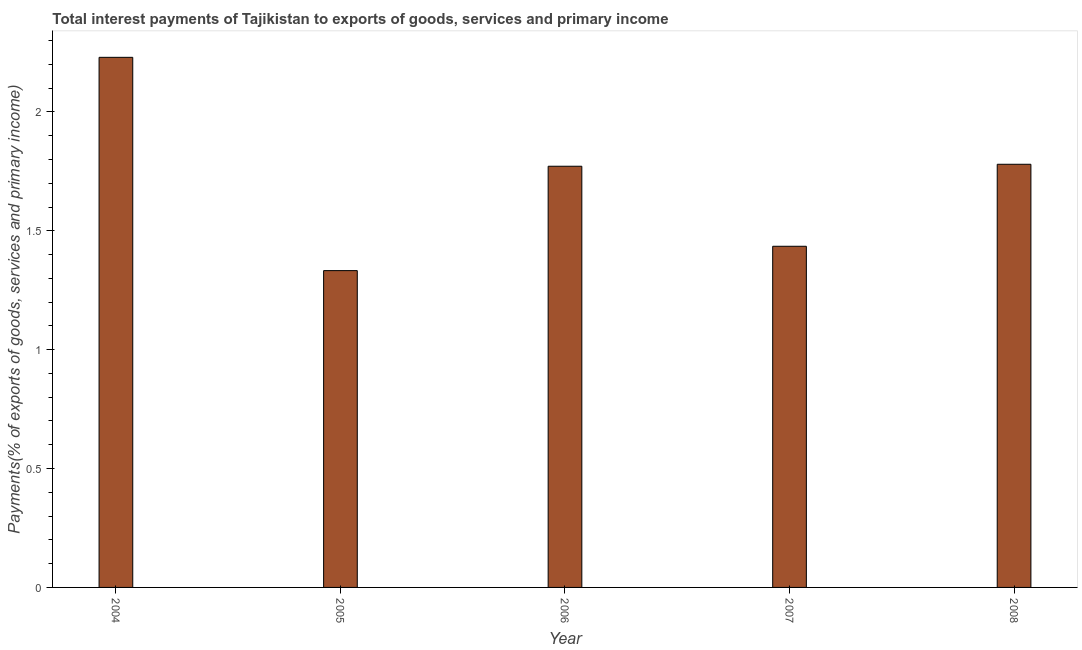Does the graph contain any zero values?
Make the answer very short. No. Does the graph contain grids?
Provide a succinct answer. No. What is the title of the graph?
Your response must be concise. Total interest payments of Tajikistan to exports of goods, services and primary income. What is the label or title of the X-axis?
Provide a succinct answer. Year. What is the label or title of the Y-axis?
Ensure brevity in your answer.  Payments(% of exports of goods, services and primary income). What is the total interest payments on external debt in 2006?
Offer a terse response. 1.77. Across all years, what is the maximum total interest payments on external debt?
Provide a short and direct response. 2.23. Across all years, what is the minimum total interest payments on external debt?
Offer a terse response. 1.33. What is the sum of the total interest payments on external debt?
Offer a terse response. 8.55. What is the difference between the total interest payments on external debt in 2004 and 2008?
Keep it short and to the point. 0.45. What is the average total interest payments on external debt per year?
Offer a terse response. 1.71. What is the median total interest payments on external debt?
Ensure brevity in your answer.  1.77. In how many years, is the total interest payments on external debt greater than 1 %?
Give a very brief answer. 5. What is the ratio of the total interest payments on external debt in 2007 to that in 2008?
Offer a terse response. 0.81. Is the total interest payments on external debt in 2004 less than that in 2008?
Make the answer very short. No. What is the difference between the highest and the second highest total interest payments on external debt?
Your answer should be compact. 0.45. Is the sum of the total interest payments on external debt in 2006 and 2008 greater than the maximum total interest payments on external debt across all years?
Offer a terse response. Yes. What is the difference between the highest and the lowest total interest payments on external debt?
Provide a short and direct response. 0.9. In how many years, is the total interest payments on external debt greater than the average total interest payments on external debt taken over all years?
Make the answer very short. 3. How many bars are there?
Offer a terse response. 5. How many years are there in the graph?
Give a very brief answer. 5. What is the Payments(% of exports of goods, services and primary income) in 2004?
Your response must be concise. 2.23. What is the Payments(% of exports of goods, services and primary income) of 2005?
Ensure brevity in your answer.  1.33. What is the Payments(% of exports of goods, services and primary income) of 2006?
Your response must be concise. 1.77. What is the Payments(% of exports of goods, services and primary income) in 2007?
Provide a short and direct response. 1.43. What is the Payments(% of exports of goods, services and primary income) in 2008?
Provide a succinct answer. 1.78. What is the difference between the Payments(% of exports of goods, services and primary income) in 2004 and 2005?
Offer a very short reply. 0.9. What is the difference between the Payments(% of exports of goods, services and primary income) in 2004 and 2006?
Your answer should be compact. 0.46. What is the difference between the Payments(% of exports of goods, services and primary income) in 2004 and 2007?
Your response must be concise. 0.79. What is the difference between the Payments(% of exports of goods, services and primary income) in 2004 and 2008?
Your response must be concise. 0.45. What is the difference between the Payments(% of exports of goods, services and primary income) in 2005 and 2006?
Your answer should be very brief. -0.44. What is the difference between the Payments(% of exports of goods, services and primary income) in 2005 and 2007?
Provide a succinct answer. -0.1. What is the difference between the Payments(% of exports of goods, services and primary income) in 2005 and 2008?
Offer a very short reply. -0.45. What is the difference between the Payments(% of exports of goods, services and primary income) in 2006 and 2007?
Make the answer very short. 0.34. What is the difference between the Payments(% of exports of goods, services and primary income) in 2006 and 2008?
Keep it short and to the point. -0.01. What is the difference between the Payments(% of exports of goods, services and primary income) in 2007 and 2008?
Your answer should be compact. -0.34. What is the ratio of the Payments(% of exports of goods, services and primary income) in 2004 to that in 2005?
Your answer should be very brief. 1.67. What is the ratio of the Payments(% of exports of goods, services and primary income) in 2004 to that in 2006?
Provide a short and direct response. 1.26. What is the ratio of the Payments(% of exports of goods, services and primary income) in 2004 to that in 2007?
Your response must be concise. 1.55. What is the ratio of the Payments(% of exports of goods, services and primary income) in 2004 to that in 2008?
Make the answer very short. 1.25. What is the ratio of the Payments(% of exports of goods, services and primary income) in 2005 to that in 2006?
Provide a succinct answer. 0.75. What is the ratio of the Payments(% of exports of goods, services and primary income) in 2005 to that in 2007?
Provide a short and direct response. 0.93. What is the ratio of the Payments(% of exports of goods, services and primary income) in 2005 to that in 2008?
Ensure brevity in your answer.  0.75. What is the ratio of the Payments(% of exports of goods, services and primary income) in 2006 to that in 2007?
Offer a very short reply. 1.24. What is the ratio of the Payments(% of exports of goods, services and primary income) in 2007 to that in 2008?
Give a very brief answer. 0.81. 